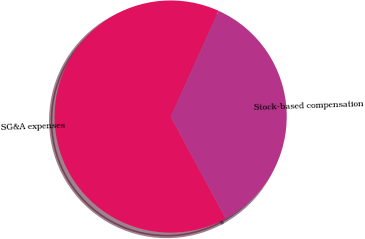Convert chart to OTSL. <chart><loc_0><loc_0><loc_500><loc_500><pie_chart><fcel>SG&A expenses<fcel>Stock-based compensation<nl><fcel>64.65%<fcel>35.35%<nl></chart> 